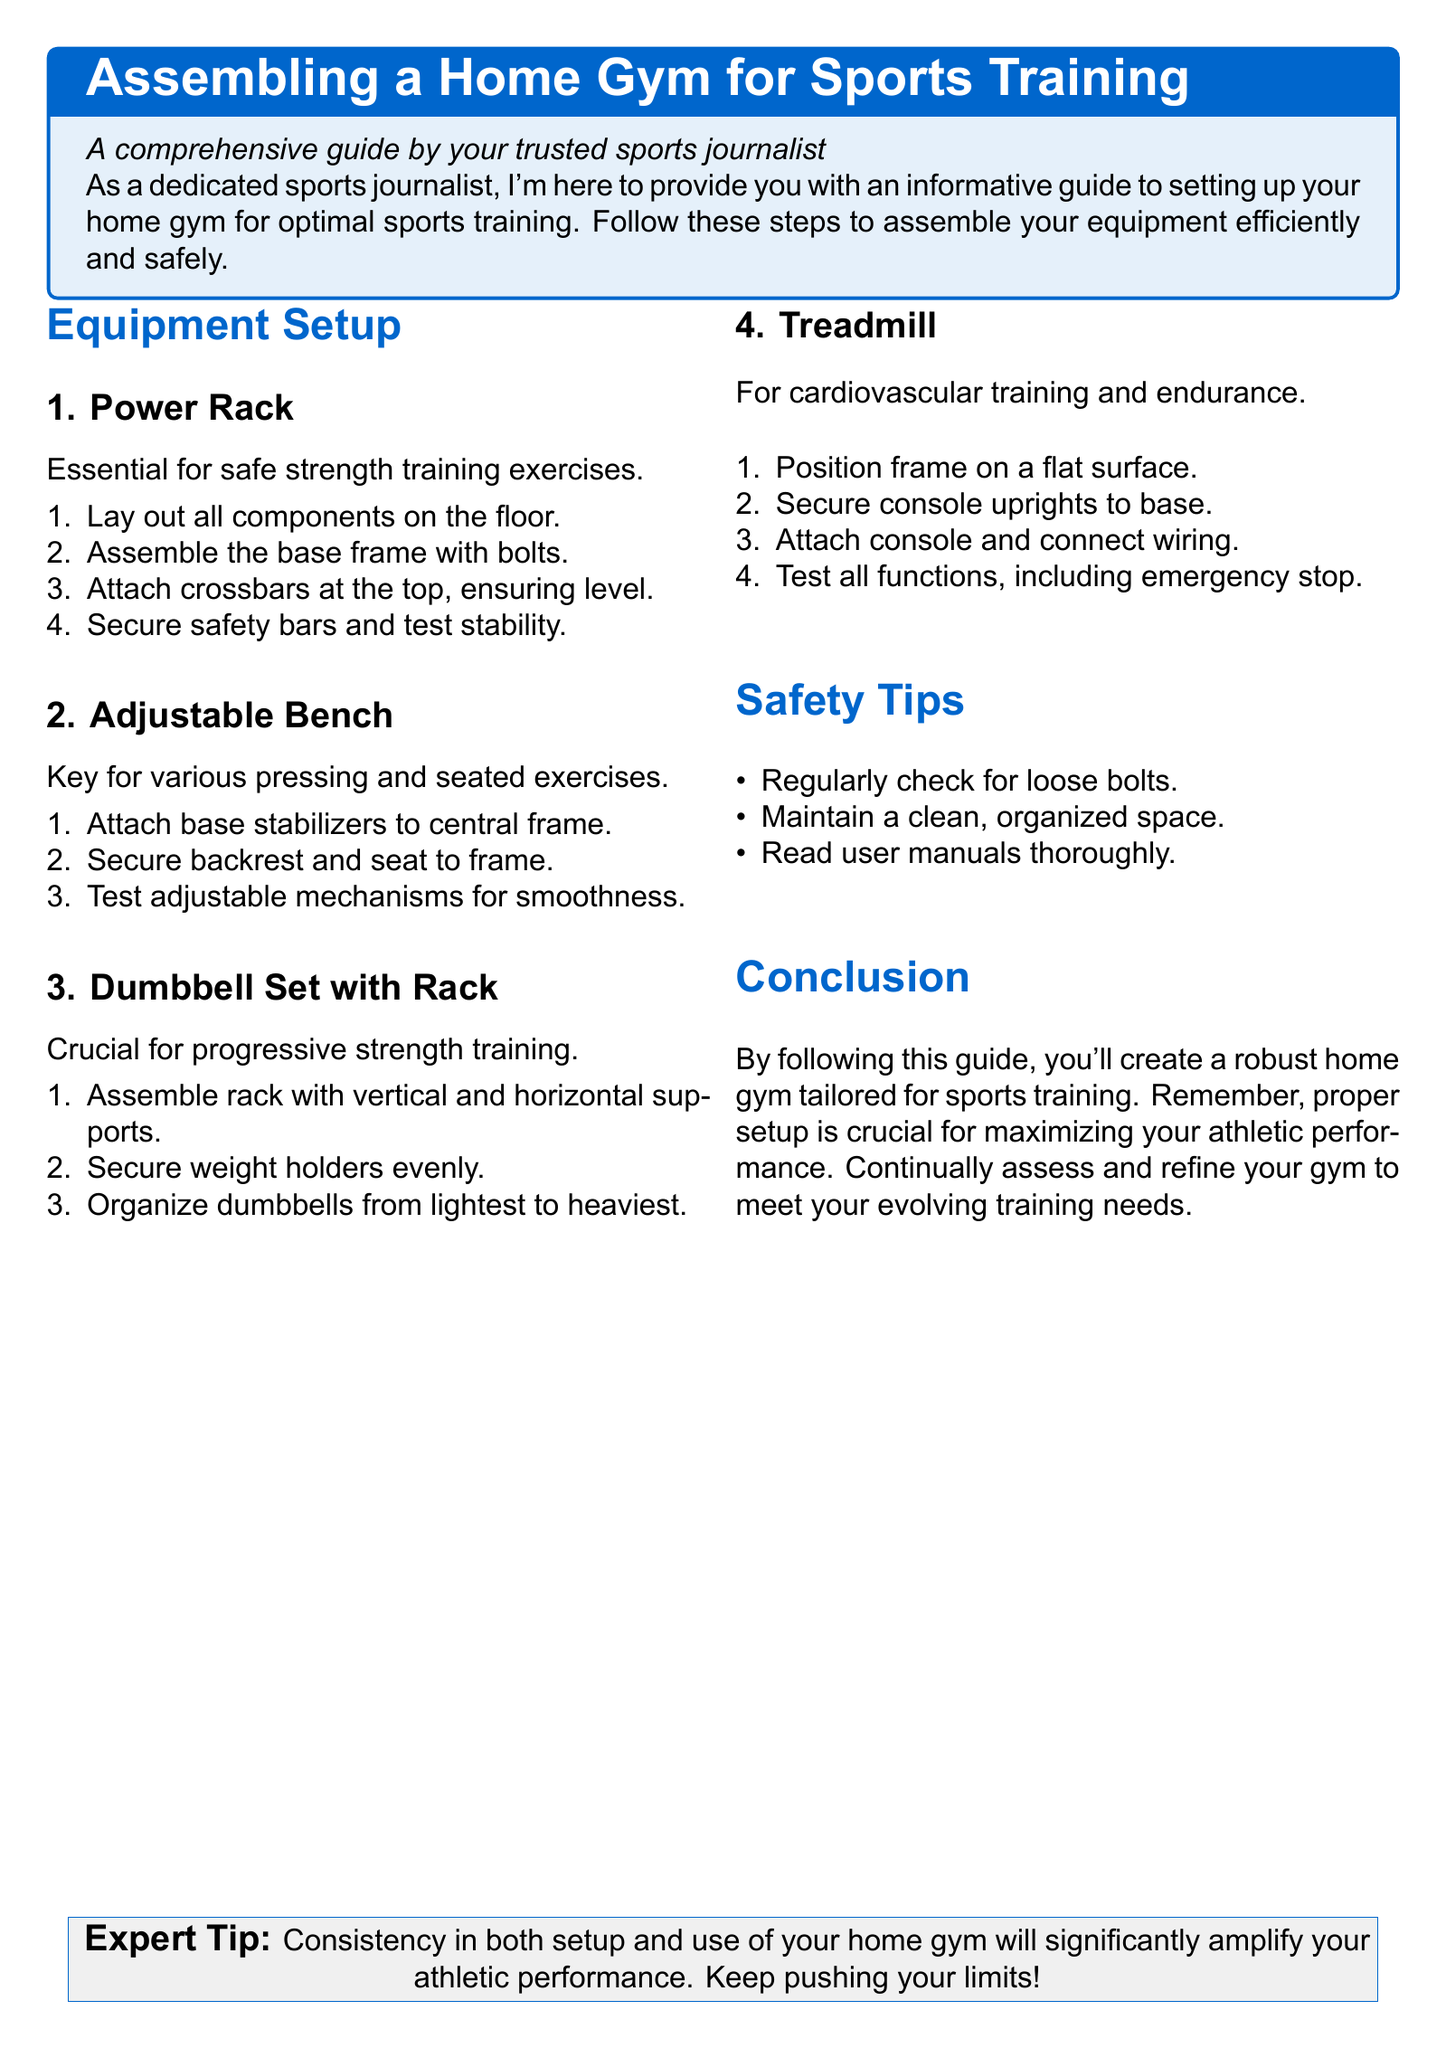What is the title of the document? The title of the document is found in the tcolorbox at the beginning and highlights the main topic.
Answer: Assembling a Home Gym for Sports Training How many subsections are there under Equipment Setup? The document outlines specific pieces of equipment, categorized into different subsections under Equipment Setup.
Answer: Four What component is essential for safe strength training exercises? The document explicitly states which piece of equipment is critical for this purpose in the first subsection.
Answer: Power Rack What should be organized from lightest to heaviest? The instructions for organizing equipment specify a clear ordering system for this item in the third subsection.
Answer: Dumbbells What is the purpose of the treadmill according to the document? The document directly states the main function of the treadmill in the corresponding subsection.
Answer: Cardiovascular training What safety tip is mentioned in the document? One of the safety tips mentioned emphasizes the importance of equipment maintenance and workspace organization.
Answer: Regularly check for loose bolts How should you test all functions of the treadmill? The document advises to check the operation of a safety feature during setup to ensure the device works properly.
Answer: Emergency stop What expert tip does the document provide? There is a noteworthy suggestion provided in the conclusion section that emphasizes an important aspect of home gym use.
Answer: Consistency in both setup and use 